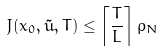Convert formula to latex. <formula><loc_0><loc_0><loc_500><loc_500>J ( x _ { 0 } , \tilde { u } , T ) \leq \left \lceil \frac { T } { L } \right \rceil \rho _ { N }</formula> 